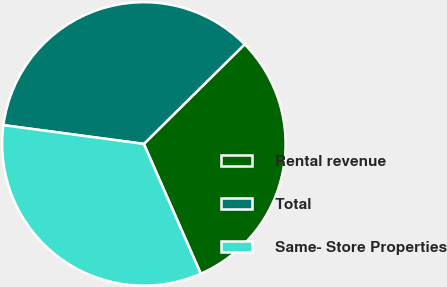<chart> <loc_0><loc_0><loc_500><loc_500><pie_chart><fcel>Rental revenue<fcel>Total<fcel>Same- Store Properties<nl><fcel>30.83%<fcel>35.48%<fcel>33.69%<nl></chart> 